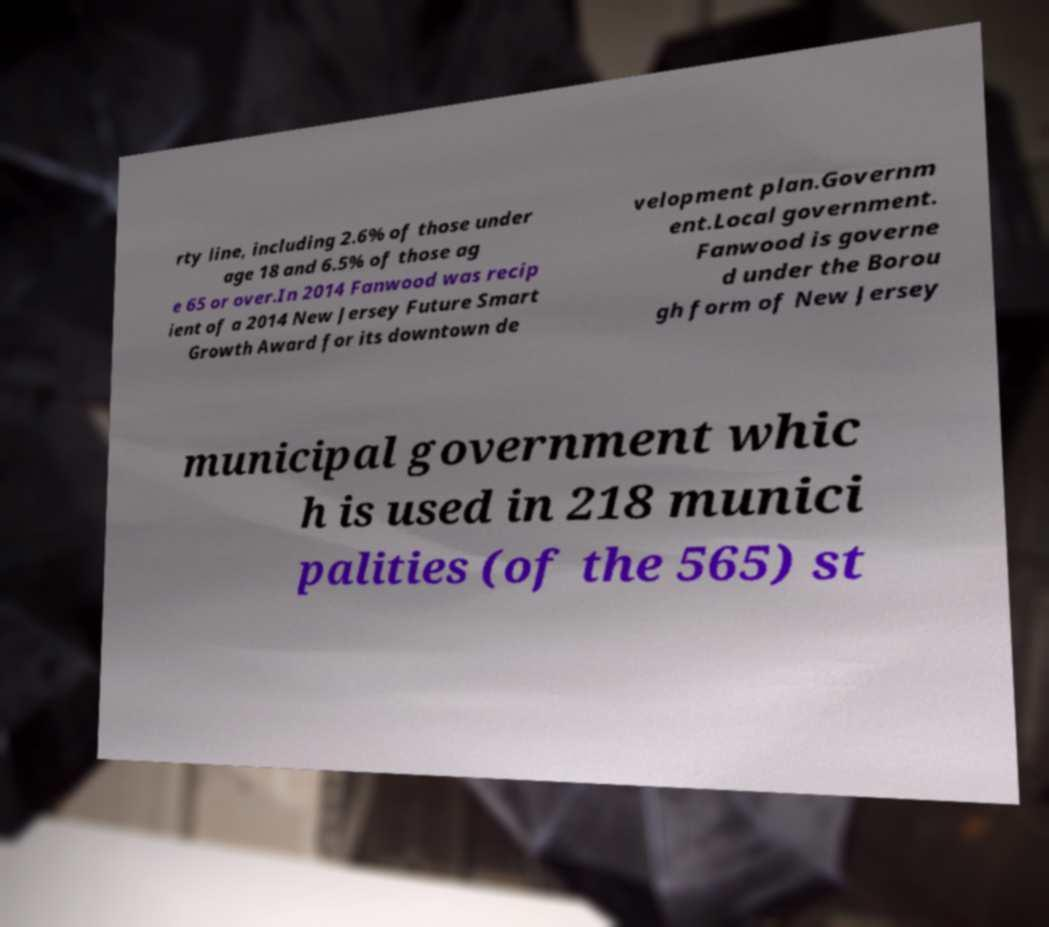Could you assist in decoding the text presented in this image and type it out clearly? rty line, including 2.6% of those under age 18 and 6.5% of those ag e 65 or over.In 2014 Fanwood was recip ient of a 2014 New Jersey Future Smart Growth Award for its downtown de velopment plan.Governm ent.Local government. Fanwood is governe d under the Borou gh form of New Jersey municipal government whic h is used in 218 munici palities (of the 565) st 